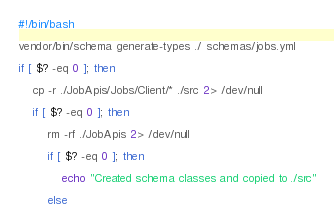Convert code to text. <code><loc_0><loc_0><loc_500><loc_500><_Bash_>#!/bin/bash

vendor/bin/schema generate-types ./ schemas/jobs.yml

if [ $? -eq 0 ]; then

    cp -r ./JobApis/Jobs/Client/* ./src 2> /dev/null

    if [ $? -eq 0 ]; then

        rm -rf ./JobApis 2> /dev/null

        if [ $? -eq 0 ]; then

            echo "Created schema classes and copied to ./src"

        else
</code> 